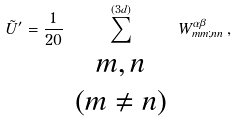Convert formula to latex. <formula><loc_0><loc_0><loc_500><loc_500>\tilde { U } ^ { \prime } = \frac { 1 } { 2 0 } \sum _ { \begin{array} { c } m , n \\ ( m \neq n ) \end{array} } ^ { ( 3 d ) } W _ { m m ; n n } ^ { \alpha \beta } \, , \\</formula> 